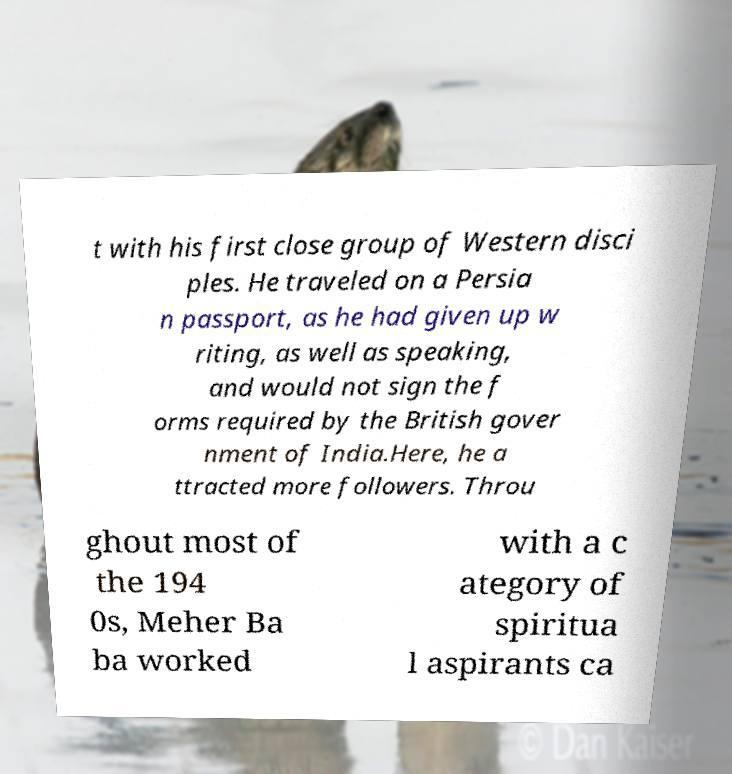Please identify and transcribe the text found in this image. t with his first close group of Western disci ples. He traveled on a Persia n passport, as he had given up w riting, as well as speaking, and would not sign the f orms required by the British gover nment of India.Here, he a ttracted more followers. Throu ghout most of the 194 0s, Meher Ba ba worked with a c ategory of spiritua l aspirants ca 